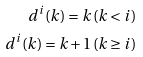<formula> <loc_0><loc_0><loc_500><loc_500>d ^ { i } ( k ) = k \, ( k < i ) \\ d ^ { i } ( k ) = k + 1 \, ( k \geq i )</formula> 